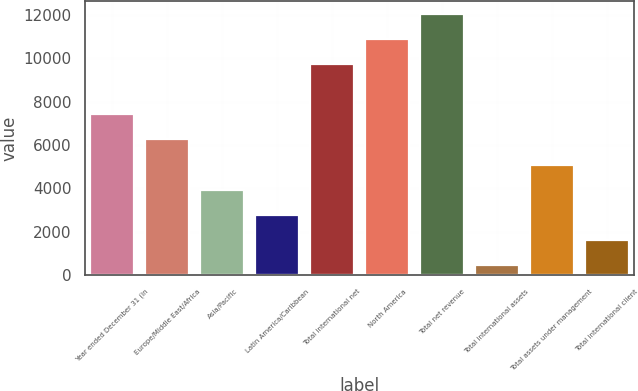Convert chart to OTSL. <chart><loc_0><loc_0><loc_500><loc_500><bar_chart><fcel>Year ended December 31 (in<fcel>Europe/Middle East/Africa<fcel>Asia/Pacific<fcel>Latin America/Caribbean<fcel>Total international net<fcel>North America<fcel>Total net revenue<fcel>Total international assets<fcel>Total assets under management<fcel>Total international client<nl><fcel>7417.8<fcel>6261<fcel>3947.4<fcel>2790.6<fcel>9731.4<fcel>10888.2<fcel>12045<fcel>477<fcel>5104.2<fcel>1633.8<nl></chart> 